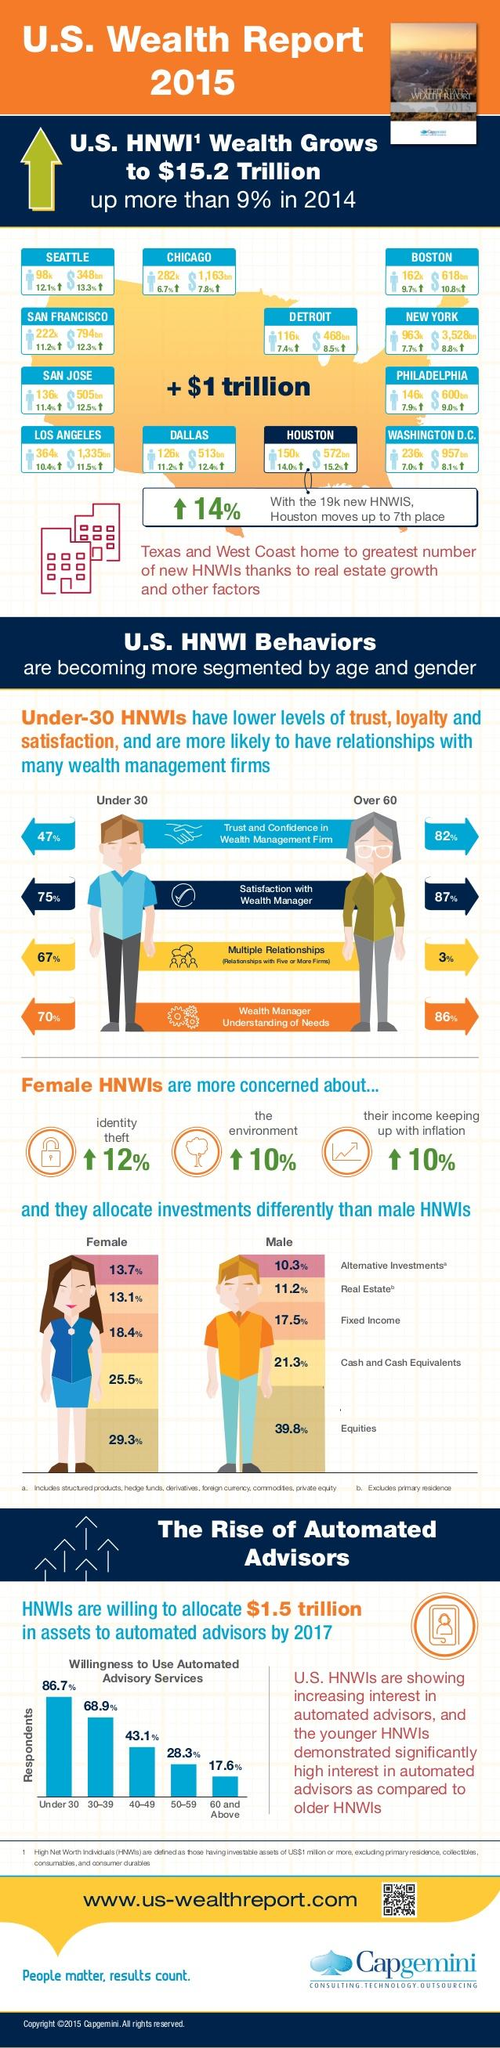List a handful of essential elements in this visual. According to the survey, individuals over the age of 60 are more likely to have relationships with only one wealth management firm. High net worth individuals (HNWIs) who are male are more likely to invest in equities, according to a study. Increase in percentage of female High Net Worth Individuals (HNWIs) showing concern for the environment is 10%. According to a recent study, 13.1% of female High Net Worth Individuals (HNWIs) invest in real estate. According to the data provided, individuals over the age of 60 tend to show more trust and confidence in wealth management firms than any other age group. 